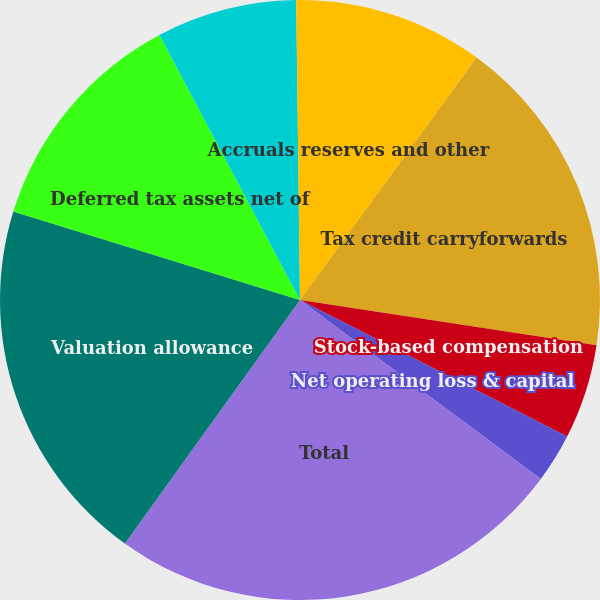<chart> <loc_0><loc_0><loc_500><loc_500><pie_chart><fcel>Accruals reserves and other<fcel>Tax credit carryforwards<fcel>Stock-based compensation<fcel>Net operating loss & capital<fcel>Total<fcel>Valuation allowance<fcel>Deferred tax assets net of<fcel>Amortization and depreciation<fcel>Prepaids and other liabilities<nl><fcel>10.02%<fcel>17.39%<fcel>5.11%<fcel>2.65%<fcel>24.75%<fcel>19.84%<fcel>12.48%<fcel>7.56%<fcel>0.2%<nl></chart> 